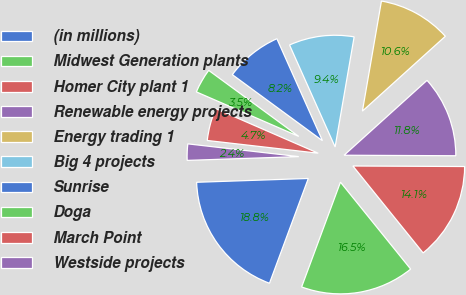Convert chart to OTSL. <chart><loc_0><loc_0><loc_500><loc_500><pie_chart><fcel>(in millions)<fcel>Midwest Generation plants<fcel>Homer City plant 1<fcel>Renewable energy projects<fcel>Energy trading 1<fcel>Big 4 projects<fcel>Sunrise<fcel>Doga<fcel>March Point<fcel>Westside projects<nl><fcel>18.81%<fcel>16.46%<fcel>14.11%<fcel>11.76%<fcel>10.59%<fcel>9.41%<fcel>8.24%<fcel>3.54%<fcel>4.71%<fcel>2.36%<nl></chart> 